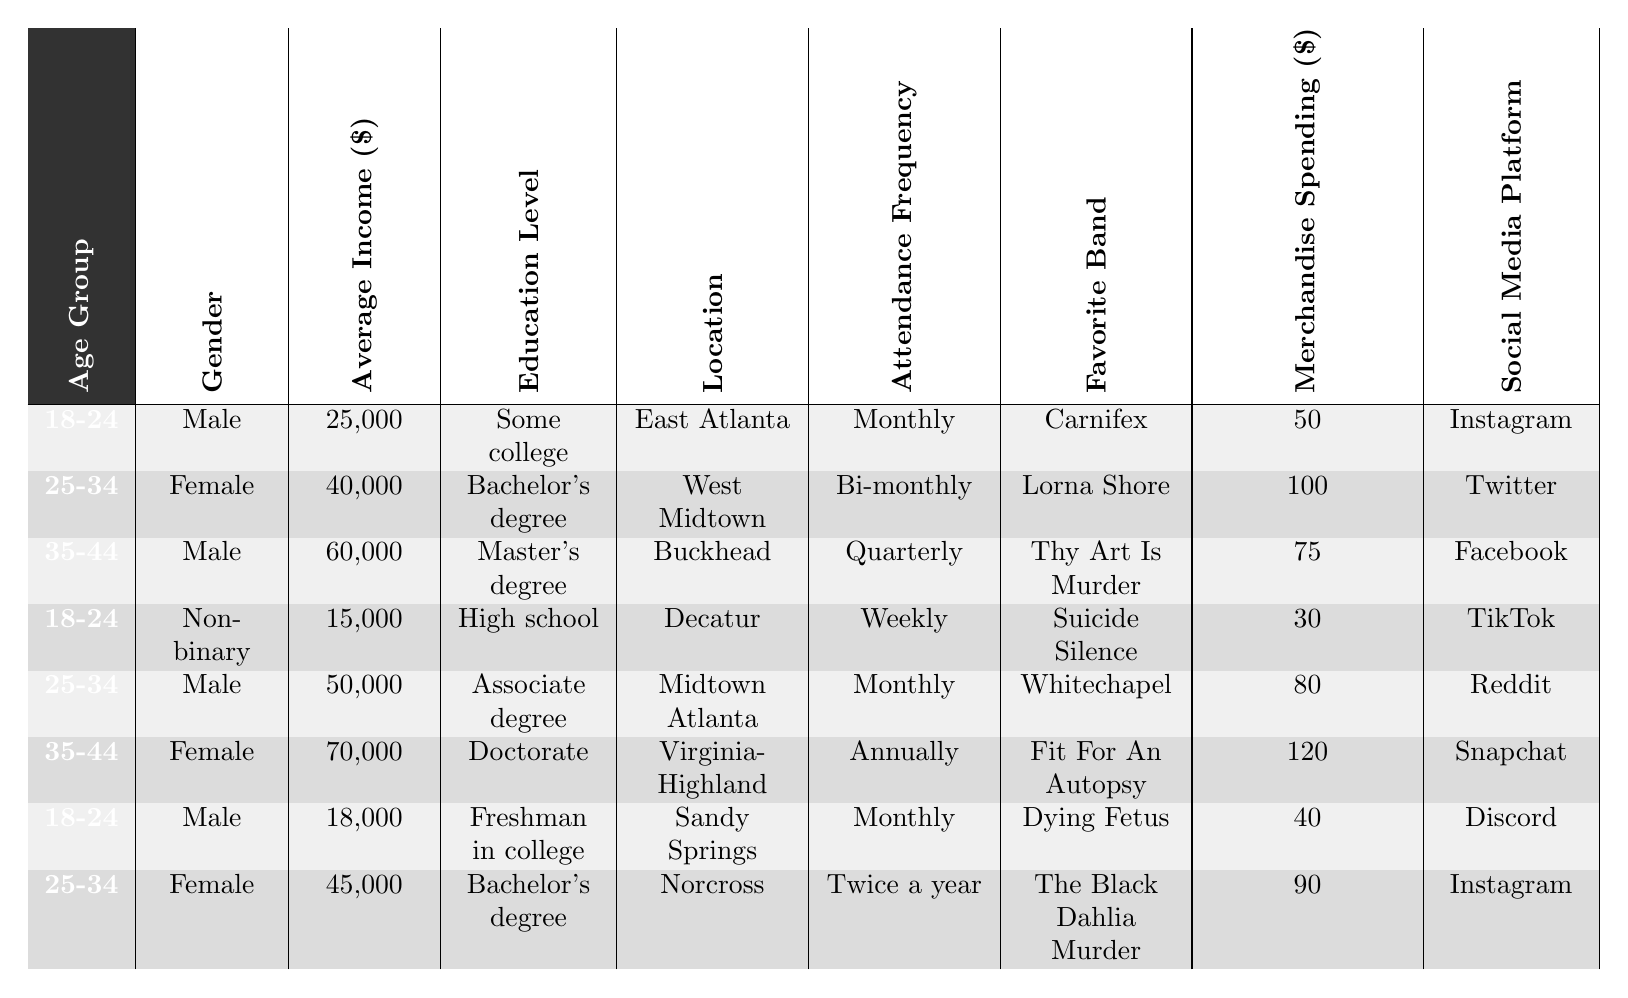What is the favorite band of the 35-44 age group who is Female? Looking at the table, the entry for the 35-44 age group that has a gender of Female lists "Fit For An Autopsy" as the favorite band.
Answer: Fit For An Autopsy How many Male deathcore fans have an average income of over $30,000? From the table, the Male fans with an income over $30,000 are two entries with incomes of $50,000 and $60,000. Therefore, there are 3 Male fans: one with $25,000, one with $18,000, and two with the higher incomes.
Answer: 2 What is the total merchandise spending for fans aged 25-34? There are three fans in the 25-34 age group with merchandise spending amounts of $100, $80, and $90. Adding them gives $100 + $80 + $90 = $270.
Answer: 270 Is there a Non-binary fan who attends events weekly? The table shows there is one Non-binary fan in the 18-24 age group who attends events weekly.
Answer: Yes What is the average merchandise spending for fans in the 18-24 age group? The 18-24 age group has three fans with merchandise spending of $50, $30, and $40. The average is calculated as (50 + 30 + 40) / 3 = 120 / 3 = 40.
Answer: 40 Which location has the fan with the highest average income? The table lists the average incomes by location, with the highest being $70,000 from Virginia-Highland.
Answer: Virginia-Highland What percentage of fans in the table are attending events monthly? There are a total of 8 fans in the table, with 4 of them (50%) attending events monthly.
Answer: 50% Is it true that most fans prefer Instagram or TikTok as their social media platform? There are 3 fans who prefer Instagram and 1 fan who prefers TikTok. Since there are more fans that prefer Instagram, it is true that among these two platforms, most fans prefer Instagram.
Answer: True What is the gender distribution of fans aged 25-34 in terms of percentage? In the 25-34 age group, there are three female fans and two male fans, making the distribution 60% Female and 40% Male.
Answer: 60% Female, 40% Male What is the highest frequency of event attendance among humans aged 35-44? Looking at the 35-44 age group, the highest frequency is the annual attendance of the female fan from Virginia-Highland.
Answer: Annually 